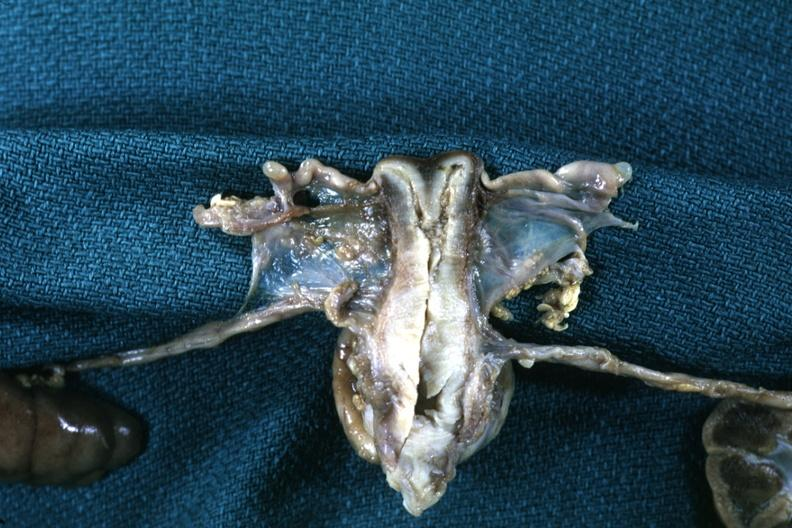what is present?
Answer the question using a single word or phrase. Cervix duplication 